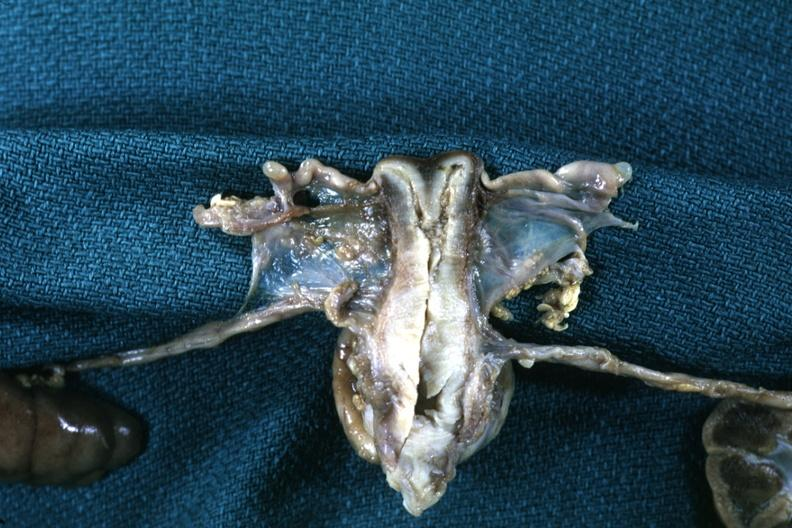what is present?
Answer the question using a single word or phrase. Cervix duplication 